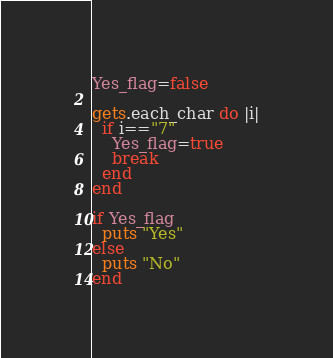<code> <loc_0><loc_0><loc_500><loc_500><_Ruby_>Yes_flag=false

gets.each_char do |i|
  if i=="7"
    Yes_flag=true
    break
  end
end

if Yes_flag
  puts "Yes" 
else
  puts "No"
end 
</code> 